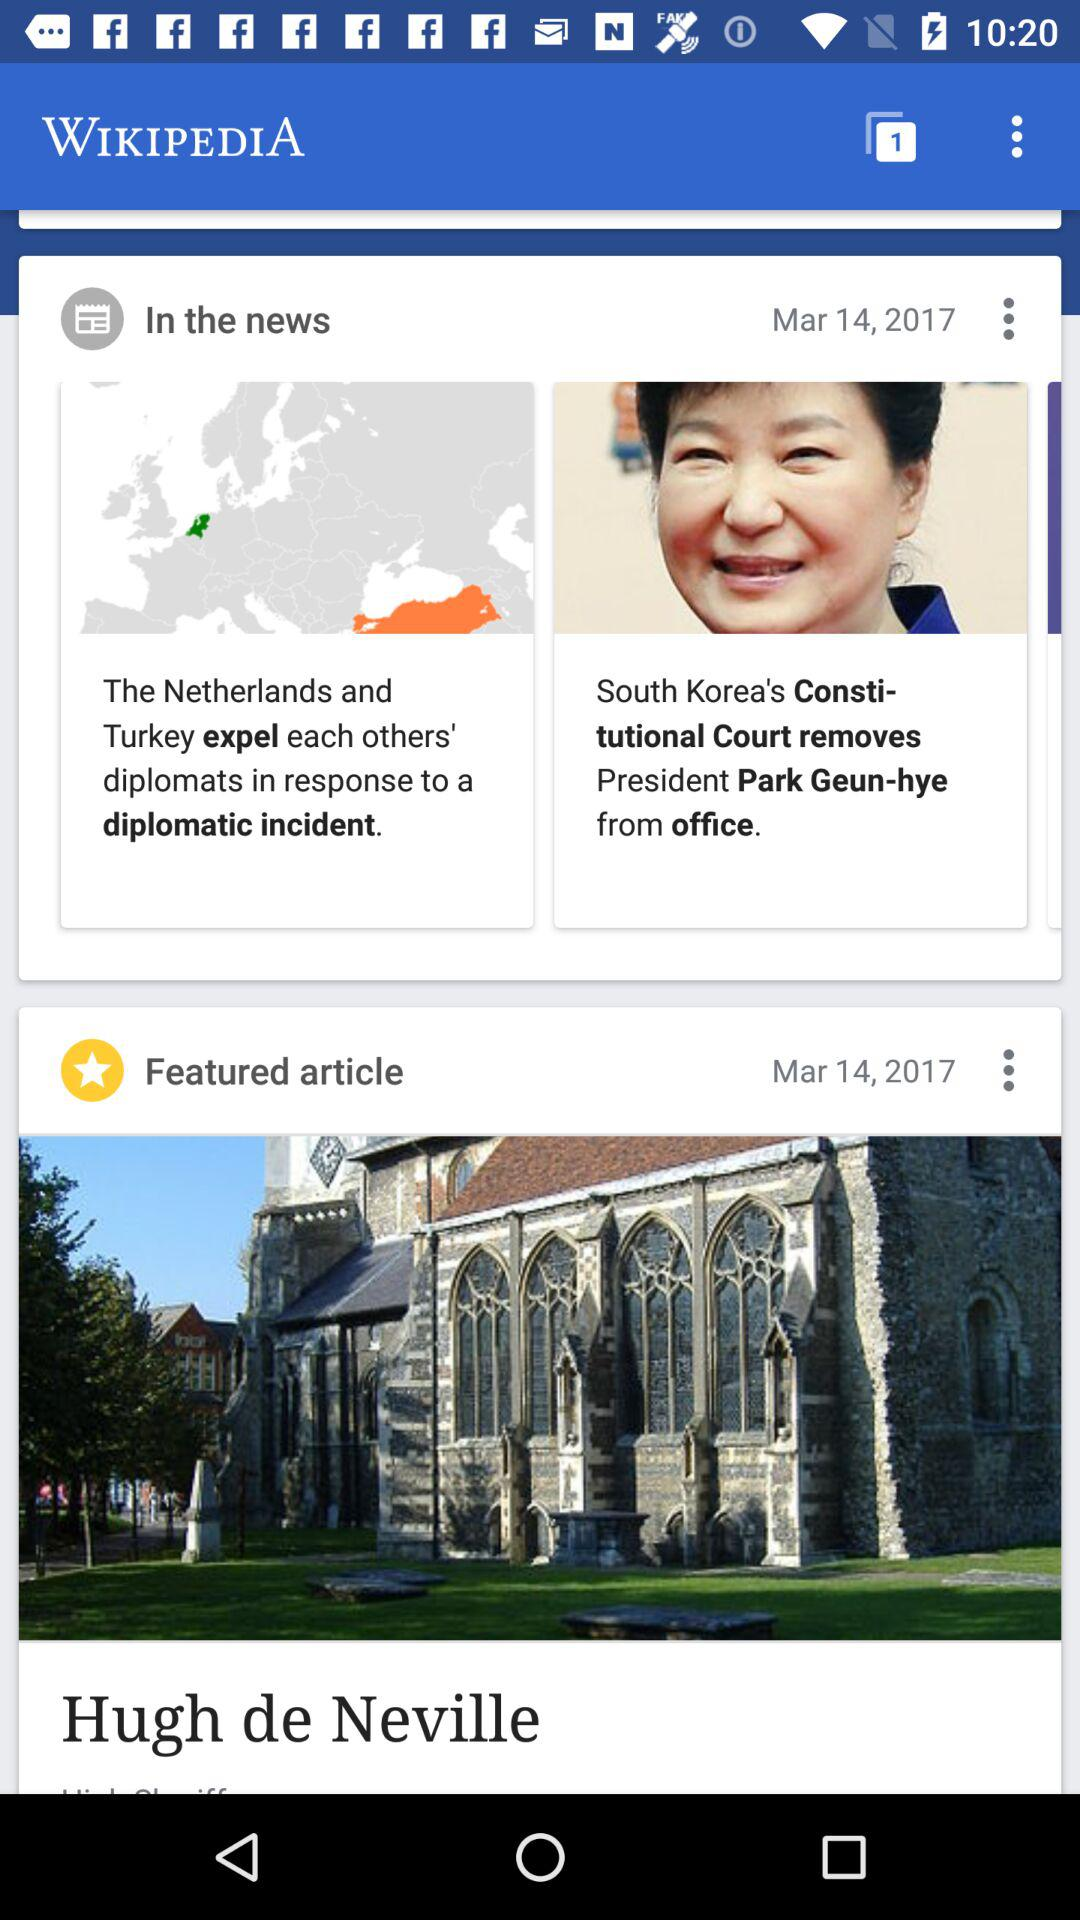How many tabs are open on this page? There is 1 tab open on this page. 